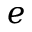<formula> <loc_0><loc_0><loc_500><loc_500>e</formula> 